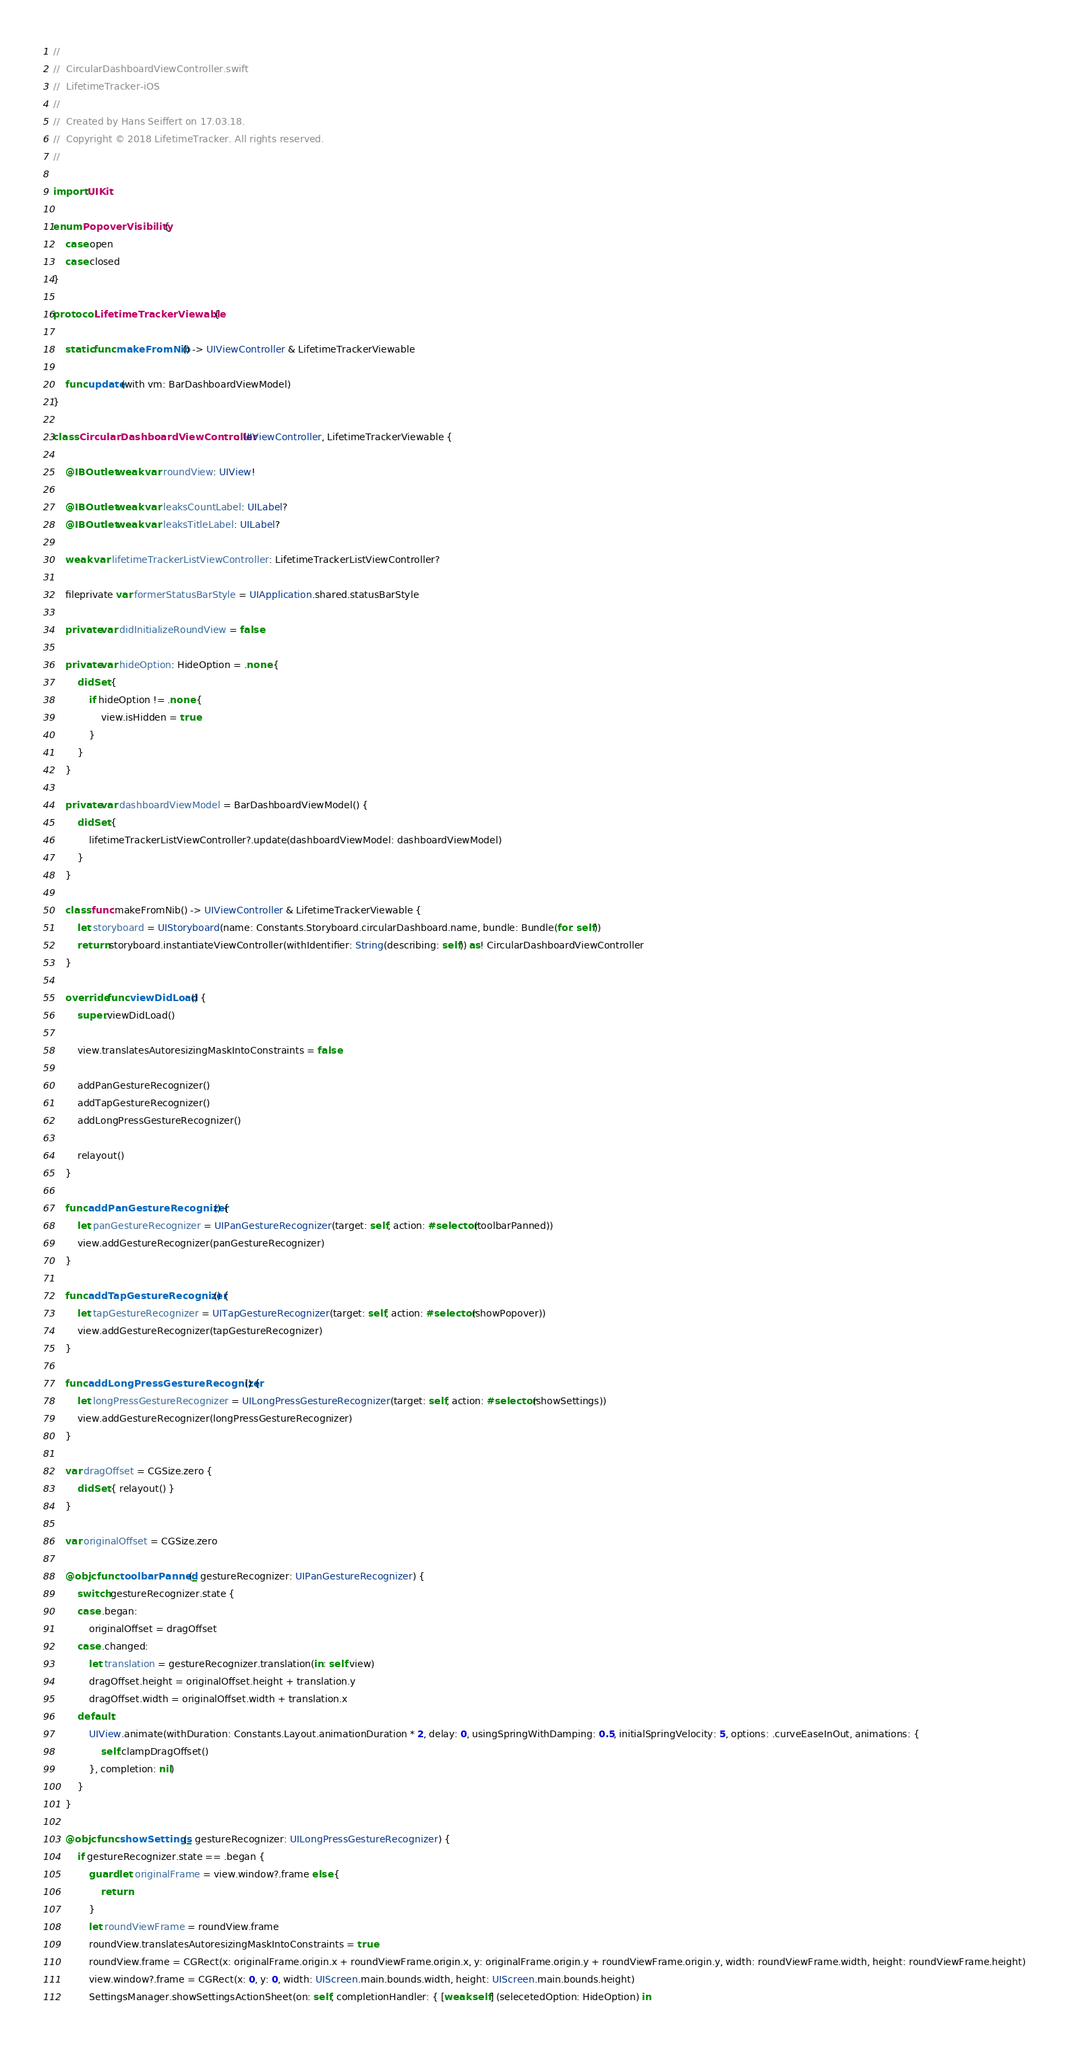<code> <loc_0><loc_0><loc_500><loc_500><_Swift_>//
//  CircularDashboardViewController.swift
//  LifetimeTracker-iOS
//
//  Created by Hans Seiffert on 17.03.18.
//  Copyright © 2018 LifetimeTracker. All rights reserved.
//

import UIKit

enum PopoverVisibility {
    case open
    case closed
}

protocol LifetimeTrackerViewable {

    static func makeFromNib() -> UIViewController & LifetimeTrackerViewable

    func update(with vm: BarDashboardViewModel)
}

class CircularDashboardViewController: UIViewController, LifetimeTrackerViewable {

    @IBOutlet weak var roundView: UIView!

    @IBOutlet weak var leaksCountLabel: UILabel?
    @IBOutlet weak var leaksTitleLabel: UILabel?

    weak var lifetimeTrackerListViewController: LifetimeTrackerListViewController?

    fileprivate var formerStatusBarStyle = UIApplication.shared.statusBarStyle

    private var didInitializeRoundView = false

    private var hideOption: HideOption = .none {
        didSet {
            if hideOption != .none {
                view.isHidden = true
            }
        }
    }

    private var dashboardViewModel = BarDashboardViewModel() {
        didSet {
            lifetimeTrackerListViewController?.update(dashboardViewModel: dashboardViewModel)
        }
    }

    class func makeFromNib() -> UIViewController & LifetimeTrackerViewable {
        let storyboard = UIStoryboard(name: Constants.Storyboard.circularDashboard.name, bundle: Bundle(for: self))
        return storyboard.instantiateViewController(withIdentifier: String(describing: self)) as! CircularDashboardViewController
    }

    override func viewDidLoad() {
        super.viewDidLoad()

        view.translatesAutoresizingMaskIntoConstraints = false

        addPanGestureRecognizer()
        addTapGestureRecognizer()
        addLongPressGestureRecognizer()

        relayout()
    }

    func addPanGestureRecognizer() {
        let panGestureRecognizer = UIPanGestureRecognizer(target: self, action: #selector(toolbarPanned))
        view.addGestureRecognizer(panGestureRecognizer)
    }

    func addTapGestureRecognizer() {
        let tapGestureRecognizer = UITapGestureRecognizer(target: self, action: #selector(showPopover))
        view.addGestureRecognizer(tapGestureRecognizer)
    }

    func addLongPressGestureRecognizer() {
        let longPressGestureRecognizer = UILongPressGestureRecognizer(target: self, action: #selector(showSettings))
        view.addGestureRecognizer(longPressGestureRecognizer)
    }

    var dragOffset = CGSize.zero {
        didSet { relayout() }
    }

    var originalOffset = CGSize.zero

    @objc func toolbarPanned(_ gestureRecognizer: UIPanGestureRecognizer) {
        switch gestureRecognizer.state {
        case .began:
            originalOffset = dragOffset
        case .changed:
            let translation = gestureRecognizer.translation(in: self.view)
            dragOffset.height = originalOffset.height + translation.y
            dragOffset.width = originalOffset.width + translation.x
        default:
            UIView.animate(withDuration: Constants.Layout.animationDuration * 2, delay: 0, usingSpringWithDamping: 0.5, initialSpringVelocity: 5, options: .curveEaseInOut, animations: {
                self.clampDragOffset()
            }, completion: nil)
        }
    }

    @objc func showSettings(_ gestureRecognizer: UILongPressGestureRecognizer) {
        if gestureRecognizer.state == .began {
            guard let originalFrame = view.window?.frame else {
                return
            }
            let roundViewFrame = roundView.frame
            roundView.translatesAutoresizingMaskIntoConstraints = true
            roundView.frame = CGRect(x: originalFrame.origin.x + roundViewFrame.origin.x, y: originalFrame.origin.y + roundViewFrame.origin.y, width: roundViewFrame.width, height: roundViewFrame.height)
            view.window?.frame = CGRect(x: 0, y: 0, width: UIScreen.main.bounds.width, height: UIScreen.main.bounds.height)
            SettingsManager.showSettingsActionSheet(on: self, completionHandler: { [weak self] (selecetedOption: HideOption) in</code> 